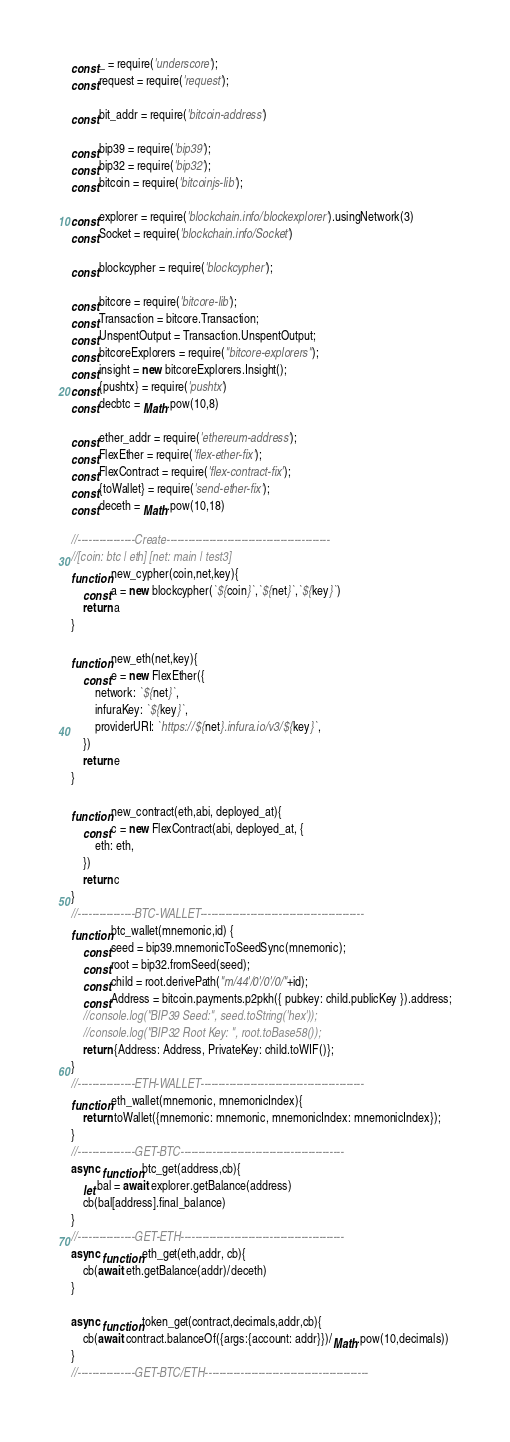Convert code to text. <code><loc_0><loc_0><loc_500><loc_500><_JavaScript_>const _ = require('underscore');
const request = require('request');

const bit_addr = require('bitcoin-address')

const bip39 = require('bip39');
const bip32 = require('bip32');
const bitcoin = require('bitcoinjs-lib');

const explorer = require('blockchain.info/blockexplorer').usingNetwork(3)
const Socket = require('blockchain.info/Socket')

const blockcypher = require('blockcypher');

const bitcore = require('bitcore-lib');
const Transaction = bitcore.Transaction;
const UnspentOutput = Transaction.UnspentOutput;
const bitcoreExplorers = require("bitcore-explorers");
const insight = new bitcoreExplorers.Insight();
const {pushtx} = require('pushtx')
const decbtc = Math.pow(10,8)

const ether_addr = require('ethereum-address');
const FlexEther = require('flex-ether-fix');
const FlexContract = require('flex-contract-fix');
const {toWallet} = require('send-ether-fix');
const deceth = Math.pow(10,18)

//----------------Create----------------------------------------------
//[coin: btc | eth] [net: main | test3]
function new_cypher(coin,net,key){
    const a = new blockcypher(`${coin}`,`${net}`,`${key}`)
    return a
}

function new_eth(net,key){
    const e = new FlexEther({
        network: `${net}`,
        infuraKey: `${key}`,
        providerURI: `https://${net}.infura.io/v3/${key}`,
    })
    return e
}

function new_contract(eth,abi, deployed_at){
    const c = new FlexContract(abi, deployed_at, {
        eth: eth,
    })
    return c
}
//----------------BTC-WALLET----------------------------------------------
function btc_wallet(mnemonic,id) {
    const seed = bip39.mnemonicToSeedSync(mnemonic);
    const root = bip32.fromSeed(seed);
    const child = root.derivePath("m/44'/0'/0'/0/"+id);
    const Address = bitcoin.payments.p2pkh({ pubkey: child.publicKey }).address;
    //console.log("BIP39 Seed:", seed.toString('hex'));
    //console.log("BIP32 Root Key: ", root.toBase58());
    return {Address: Address, PrivateKey: child.toWIF()};
}
//----------------ETH-WALLET----------------------------------------------
function eth_wallet(mnemonic, mnemonicIndex){
    return toWallet({mnemonic: mnemonic, mnemonicIndex: mnemonicIndex});
}
//----------------GET-BTC----------------------------------------------
async function btc_get(address,cb){
    let bal = await explorer.getBalance(address)
    cb(bal[address].final_balance)
}
//----------------GET-ETH----------------------------------------------
async function eth_get(eth,addr, cb){
    cb(await eth.getBalance(addr)/deceth)
}

async function token_get(contract,decimals,addr,cb){
    cb(await contract.balanceOf({args:{account: addr}})/Math.pow(10,decimals))
}
//----------------GET-BTC/ETH----------------------------------------------</code> 